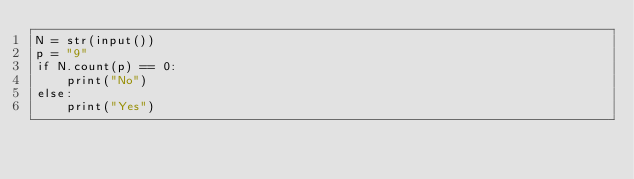Convert code to text. <code><loc_0><loc_0><loc_500><loc_500><_Python_>N = str(input())
p = "9"
if N.count(p) == 0:
    print("No")
else:
    print("Yes")</code> 